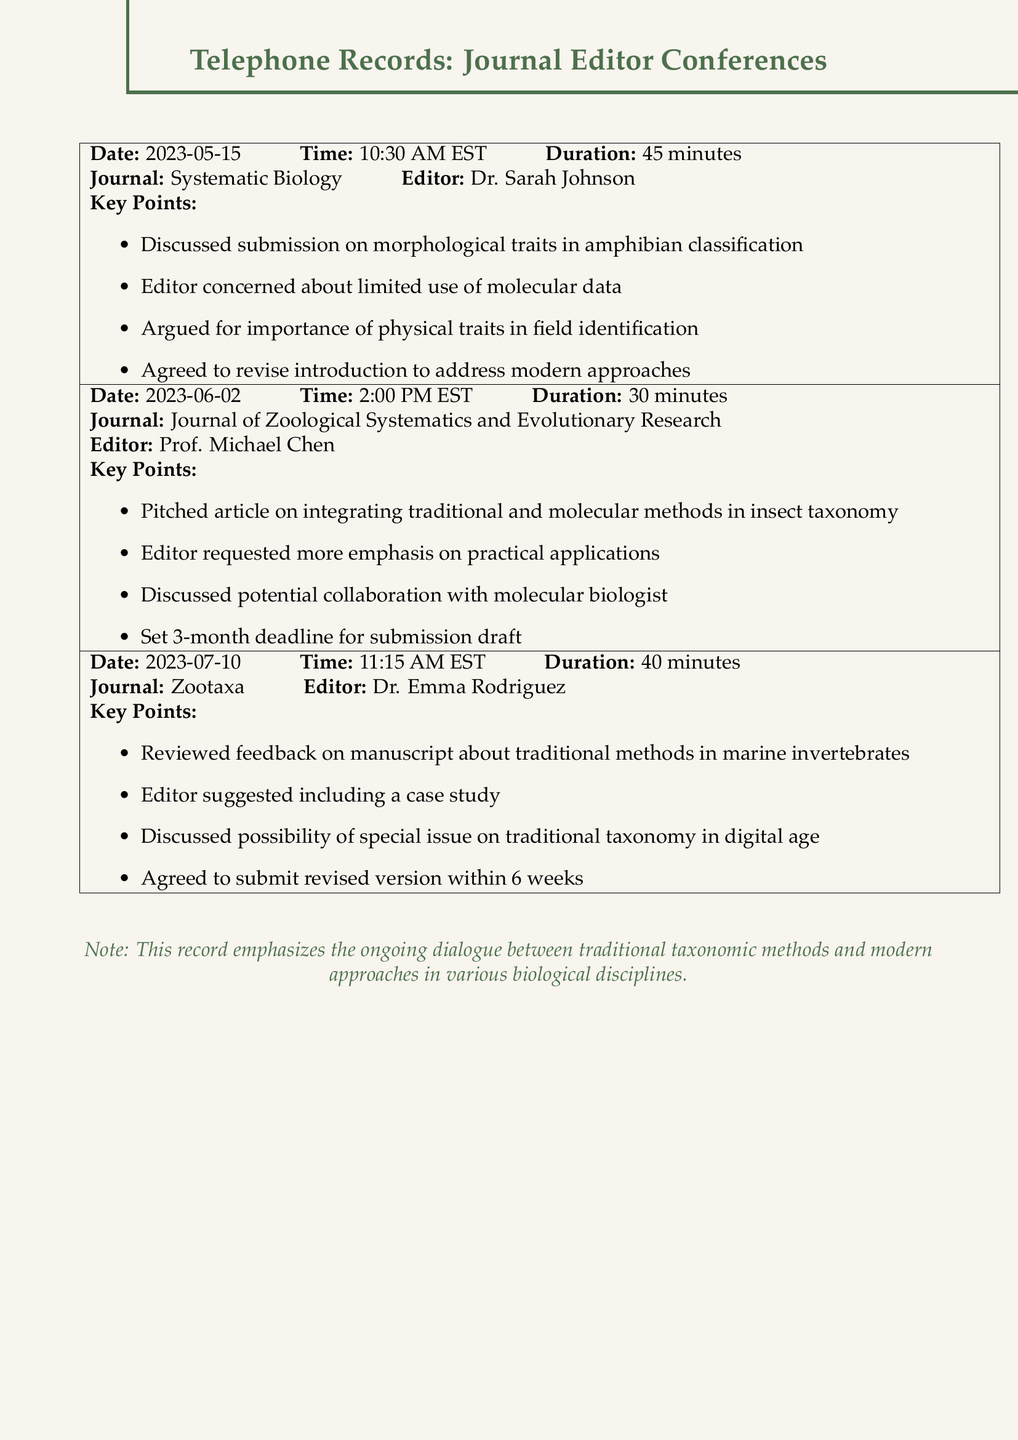What is the date of the first teleconference? The date of the first teleconference is mentioned in the document, which is 2023-05-15.
Answer: 2023-05-15 Who was the editor for the Journal of Zoological Systematics and Evolutionary Research? The editor for this journal is listed in the record as Prof. Michael Chen.
Answer: Prof. Michael Chen What was the duration of the teleconference on 2023-06-02? The duration of this specific teleconference is noted as 30 minutes.
Answer: 30 minutes What key point was discussed regarding the manuscript about traditional methods? One key point related to this manuscript is that the editor suggested including a case study.
Answer: Include a case study How long was the deadline set for the submission draft during the June 2 teleconference? The deadline for the submission draft was set at 3 months following the conversation.
Answer: 3 months What modern approach was discussed in relation to amphibian classification during the first teleconference? The modern approach discussed in this context relates to the limited use of molecular data.
Answer: Limited use of molecular data What journal did Dr. Emma Rodriguez edit? The document specifies that Dr. Emma Rodriguez is the editor for Zootaxa.
Answer: Zootaxa During which teleconference was the potential collaboration with a molecular biologist discussed? The potential collaboration was mentioned during the teleconference with Prof. Michael Chen.
Answer: Prof. Michael Chen 